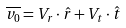Convert formula to latex. <formula><loc_0><loc_0><loc_500><loc_500>\overline { v _ { 0 } } = V _ { r } \cdot \hat { r } + V _ { t } \cdot \hat { t }</formula> 